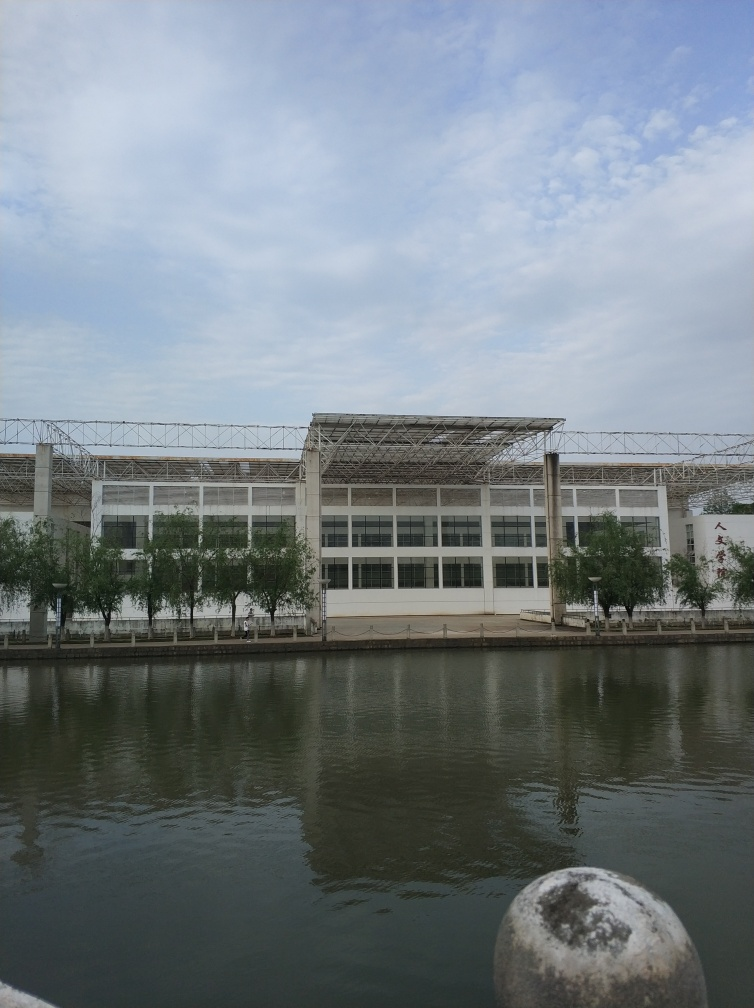Are the ripples on the water surface distinct?
A. No
B. Yes
Answer with the option's letter from the given choices directly.
 B. 